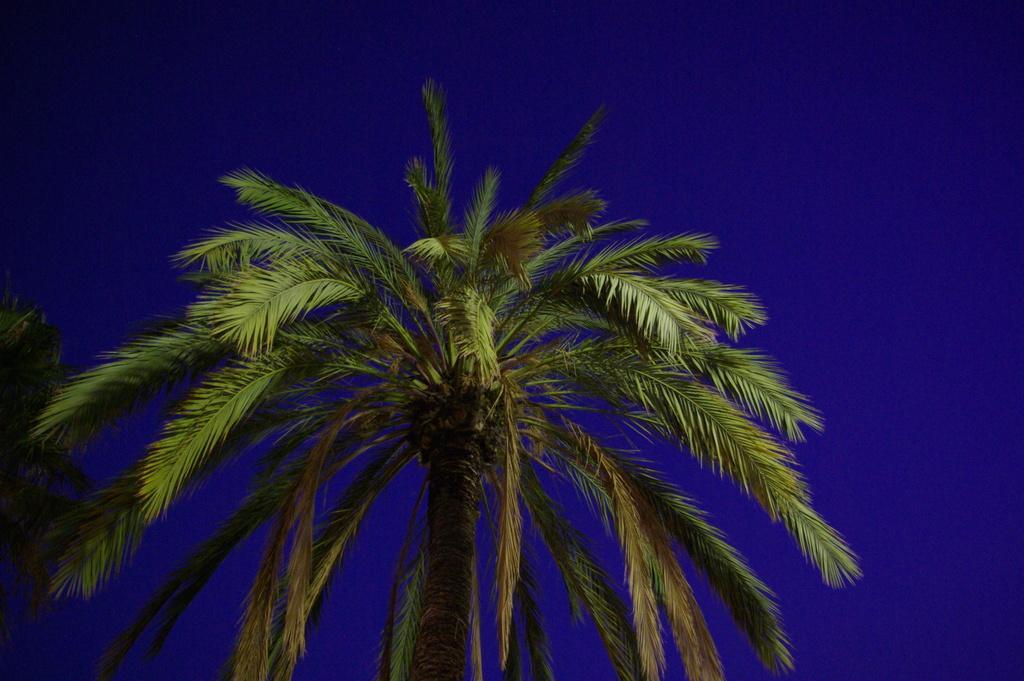Describe this image in one or two sentences. In this image we can see some trees and top of the image there is clear sky which is blue in color. 